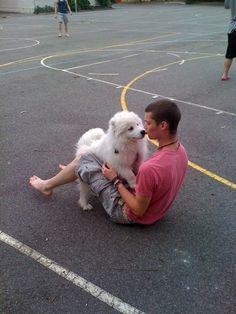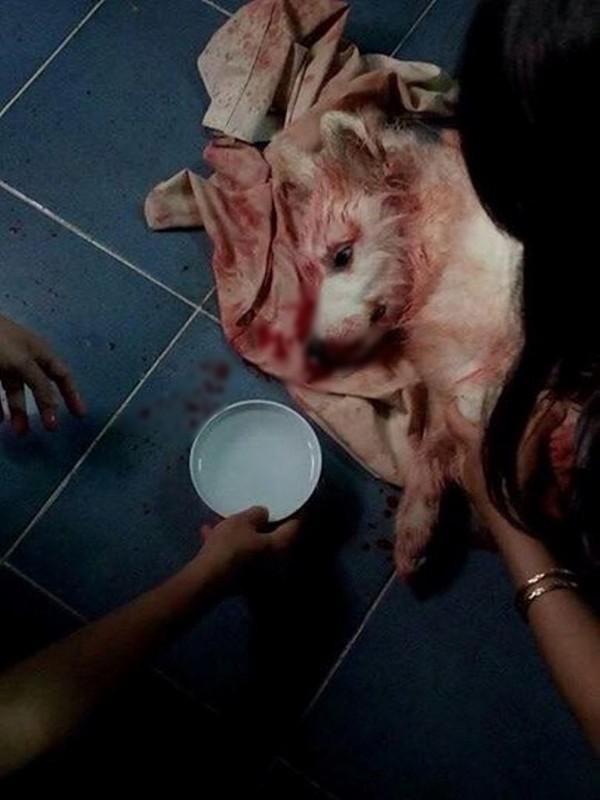The first image is the image on the left, the second image is the image on the right. Considering the images on both sides, is "A team of dogs is pulling a sled in one of the images." valid? Answer yes or no. No. The first image is the image on the left, the second image is the image on the right. Given the left and right images, does the statement "An image shows a rider in a sled behind a team of white sled dogs." hold true? Answer yes or no. No. 